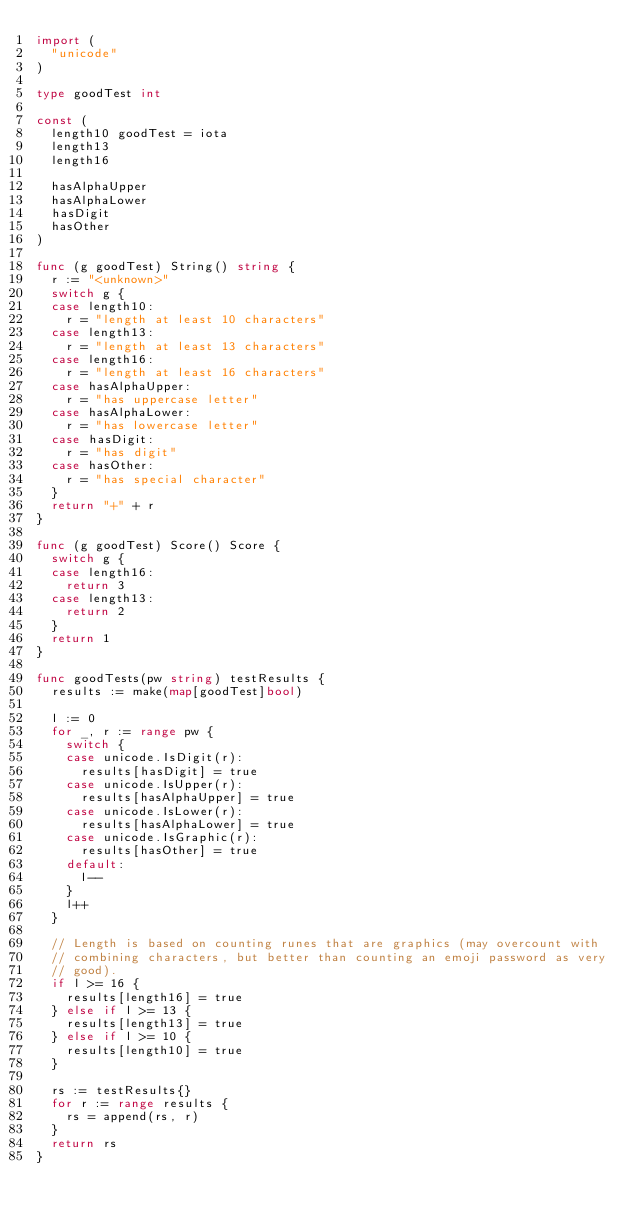<code> <loc_0><loc_0><loc_500><loc_500><_Go_>import (
	"unicode"
)

type goodTest int

const (
	length10 goodTest = iota
	length13
	length16

	hasAlphaUpper
	hasAlphaLower
	hasDigit
	hasOther
)

func (g goodTest) String() string {
	r := "<unknown>"
	switch g {
	case length10:
		r = "length at least 10 characters"
	case length13:
		r = "length at least 13 characters"
	case length16:
		r = "length at least 16 characters"
	case hasAlphaUpper:
		r = "has uppercase letter"
	case hasAlphaLower:
		r = "has lowercase letter"
	case hasDigit:
		r = "has digit"
	case hasOther:
		r = "has special character"
	}
	return "+" + r
}

func (g goodTest) Score() Score {
	switch g {
	case length16:
		return 3
	case length13:
		return 2
	}
	return 1
}

func goodTests(pw string) testResults {
	results := make(map[goodTest]bool)

	l := 0
	for _, r := range pw {
		switch {
		case unicode.IsDigit(r):
			results[hasDigit] = true
		case unicode.IsUpper(r):
			results[hasAlphaUpper] = true
		case unicode.IsLower(r):
			results[hasAlphaLower] = true
		case unicode.IsGraphic(r):
			results[hasOther] = true
		default:
			l--
		}
		l++
	}

	// Length is based on counting runes that are graphics (may overcount with
	// combining characters, but better than counting an emoji password as very
	// good).
	if l >= 16 {
		results[length16] = true
	} else if l >= 13 {
		results[length13] = true
	} else if l >= 10 {
		results[length10] = true
	}

	rs := testResults{}
	for r := range results {
		rs = append(rs, r)
	}
	return rs
}
</code> 